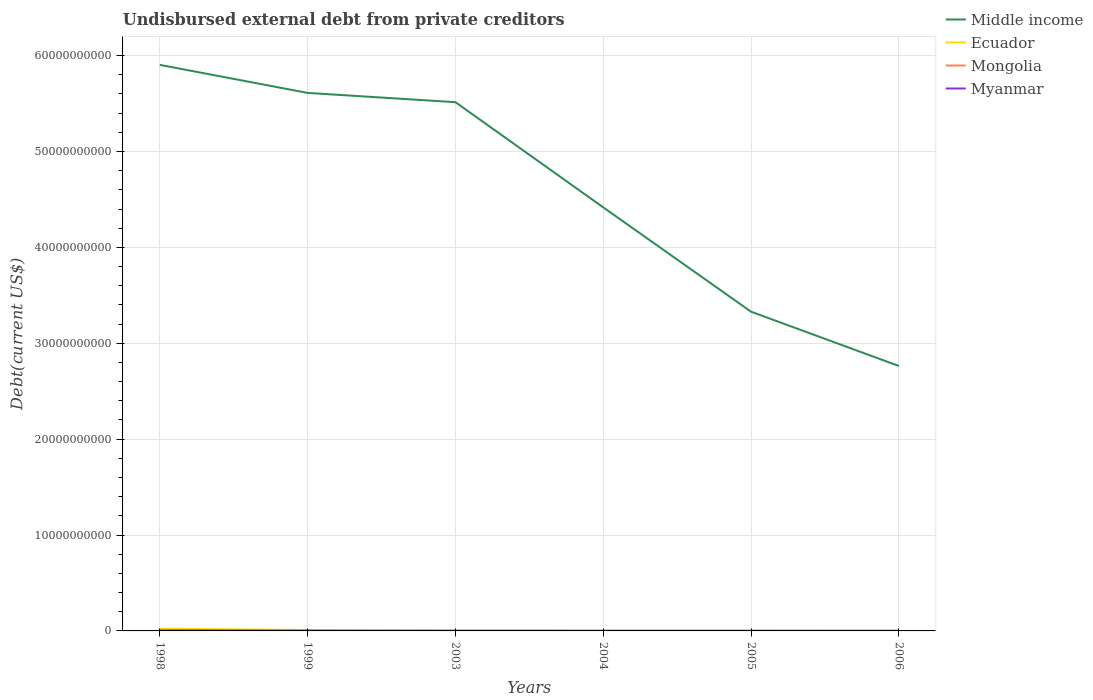How many different coloured lines are there?
Offer a terse response. 4. Is the number of lines equal to the number of legend labels?
Ensure brevity in your answer.  Yes. Across all years, what is the maximum total debt in Myanmar?
Give a very brief answer. 4.70e+04. In which year was the total debt in Myanmar maximum?
Ensure brevity in your answer.  2004. What is the total total debt in Ecuador in the graph?
Offer a terse response. 1.26e+07. What is the difference between the highest and the second highest total debt in Middle income?
Your answer should be compact. 3.14e+1. What is the difference between the highest and the lowest total debt in Middle income?
Keep it short and to the point. 3. Is the total debt in Myanmar strictly greater than the total debt in Mongolia over the years?
Provide a succinct answer. No. How many years are there in the graph?
Provide a succinct answer. 6. Are the values on the major ticks of Y-axis written in scientific E-notation?
Make the answer very short. No. Does the graph contain grids?
Your answer should be compact. Yes. How many legend labels are there?
Offer a very short reply. 4. What is the title of the graph?
Offer a very short reply. Undisbursed external debt from private creditors. What is the label or title of the Y-axis?
Your answer should be compact. Debt(current US$). What is the Debt(current US$) of Middle income in 1998?
Provide a short and direct response. 5.90e+1. What is the Debt(current US$) in Ecuador in 1998?
Offer a terse response. 2.32e+08. What is the Debt(current US$) in Mongolia in 1998?
Offer a very short reply. 8.92e+06. What is the Debt(current US$) in Myanmar in 1998?
Make the answer very short. 5.25e+07. What is the Debt(current US$) in Middle income in 1999?
Your response must be concise. 5.61e+1. What is the Debt(current US$) of Ecuador in 1999?
Provide a succinct answer. 9.39e+07. What is the Debt(current US$) in Mongolia in 1999?
Ensure brevity in your answer.  8.92e+06. What is the Debt(current US$) of Myanmar in 1999?
Your answer should be very brief. 2.32e+07. What is the Debt(current US$) in Middle income in 2003?
Your answer should be very brief. 5.51e+1. What is the Debt(current US$) of Ecuador in 2003?
Provide a short and direct response. 6.08e+07. What is the Debt(current US$) in Mongolia in 2003?
Keep it short and to the point. 2.65e+07. What is the Debt(current US$) in Myanmar in 2003?
Your answer should be compact. 1.63e+05. What is the Debt(current US$) in Middle income in 2004?
Provide a short and direct response. 4.42e+1. What is the Debt(current US$) of Ecuador in 2004?
Provide a succinct answer. 3.32e+07. What is the Debt(current US$) of Mongolia in 2004?
Your answer should be very brief. 2.65e+07. What is the Debt(current US$) of Myanmar in 2004?
Offer a terse response. 4.70e+04. What is the Debt(current US$) in Middle income in 2005?
Make the answer very short. 3.33e+1. What is the Debt(current US$) of Ecuador in 2005?
Give a very brief answer. 2.07e+07. What is the Debt(current US$) of Mongolia in 2005?
Provide a succinct answer. 2.65e+07. What is the Debt(current US$) of Myanmar in 2005?
Provide a short and direct response. 4.70e+04. What is the Debt(current US$) in Middle income in 2006?
Give a very brief answer. 2.76e+1. What is the Debt(current US$) of Ecuador in 2006?
Your answer should be compact. 4.74e+07. What is the Debt(current US$) in Mongolia in 2006?
Offer a very short reply. 8.40e+06. What is the Debt(current US$) in Myanmar in 2006?
Provide a short and direct response. 4.70e+04. Across all years, what is the maximum Debt(current US$) in Middle income?
Provide a succinct answer. 5.90e+1. Across all years, what is the maximum Debt(current US$) in Ecuador?
Make the answer very short. 2.32e+08. Across all years, what is the maximum Debt(current US$) in Mongolia?
Provide a succinct answer. 2.65e+07. Across all years, what is the maximum Debt(current US$) in Myanmar?
Your answer should be very brief. 5.25e+07. Across all years, what is the minimum Debt(current US$) in Middle income?
Your response must be concise. 2.76e+1. Across all years, what is the minimum Debt(current US$) of Ecuador?
Ensure brevity in your answer.  2.07e+07. Across all years, what is the minimum Debt(current US$) of Mongolia?
Your response must be concise. 8.40e+06. Across all years, what is the minimum Debt(current US$) of Myanmar?
Offer a terse response. 4.70e+04. What is the total Debt(current US$) of Middle income in the graph?
Ensure brevity in your answer.  2.75e+11. What is the total Debt(current US$) in Ecuador in the graph?
Make the answer very short. 4.88e+08. What is the total Debt(current US$) in Mongolia in the graph?
Offer a terse response. 1.06e+08. What is the total Debt(current US$) of Myanmar in the graph?
Your answer should be very brief. 7.60e+07. What is the difference between the Debt(current US$) of Middle income in 1998 and that in 1999?
Your answer should be very brief. 2.92e+09. What is the difference between the Debt(current US$) of Ecuador in 1998 and that in 1999?
Keep it short and to the point. 1.38e+08. What is the difference between the Debt(current US$) of Mongolia in 1998 and that in 1999?
Keep it short and to the point. 0. What is the difference between the Debt(current US$) in Myanmar in 1998 and that in 1999?
Provide a succinct answer. 2.93e+07. What is the difference between the Debt(current US$) of Middle income in 1998 and that in 2003?
Provide a short and direct response. 3.89e+09. What is the difference between the Debt(current US$) in Ecuador in 1998 and that in 2003?
Offer a very short reply. 1.71e+08. What is the difference between the Debt(current US$) of Mongolia in 1998 and that in 2003?
Make the answer very short. -1.76e+07. What is the difference between the Debt(current US$) of Myanmar in 1998 and that in 2003?
Provide a short and direct response. 5.23e+07. What is the difference between the Debt(current US$) in Middle income in 1998 and that in 2004?
Offer a very short reply. 1.49e+1. What is the difference between the Debt(current US$) in Ecuador in 1998 and that in 2004?
Your response must be concise. 1.99e+08. What is the difference between the Debt(current US$) in Mongolia in 1998 and that in 2004?
Provide a succinct answer. -1.76e+07. What is the difference between the Debt(current US$) of Myanmar in 1998 and that in 2004?
Make the answer very short. 5.24e+07. What is the difference between the Debt(current US$) in Middle income in 1998 and that in 2005?
Your answer should be compact. 2.57e+1. What is the difference between the Debt(current US$) of Ecuador in 1998 and that in 2005?
Your response must be concise. 2.12e+08. What is the difference between the Debt(current US$) in Mongolia in 1998 and that in 2005?
Offer a terse response. -1.76e+07. What is the difference between the Debt(current US$) in Myanmar in 1998 and that in 2005?
Offer a very short reply. 5.24e+07. What is the difference between the Debt(current US$) of Middle income in 1998 and that in 2006?
Provide a succinct answer. 3.14e+1. What is the difference between the Debt(current US$) in Ecuador in 1998 and that in 2006?
Your answer should be very brief. 1.85e+08. What is the difference between the Debt(current US$) of Mongolia in 1998 and that in 2006?
Make the answer very short. 5.24e+05. What is the difference between the Debt(current US$) in Myanmar in 1998 and that in 2006?
Offer a very short reply. 5.24e+07. What is the difference between the Debt(current US$) in Middle income in 1999 and that in 2003?
Give a very brief answer. 9.68e+08. What is the difference between the Debt(current US$) of Ecuador in 1999 and that in 2003?
Your answer should be very brief. 3.31e+07. What is the difference between the Debt(current US$) of Mongolia in 1999 and that in 2003?
Provide a short and direct response. -1.76e+07. What is the difference between the Debt(current US$) of Myanmar in 1999 and that in 2003?
Offer a terse response. 2.30e+07. What is the difference between the Debt(current US$) of Middle income in 1999 and that in 2004?
Your answer should be very brief. 1.19e+1. What is the difference between the Debt(current US$) of Ecuador in 1999 and that in 2004?
Keep it short and to the point. 6.07e+07. What is the difference between the Debt(current US$) of Mongolia in 1999 and that in 2004?
Give a very brief answer. -1.76e+07. What is the difference between the Debt(current US$) of Myanmar in 1999 and that in 2004?
Provide a succinct answer. 2.31e+07. What is the difference between the Debt(current US$) in Middle income in 1999 and that in 2005?
Offer a very short reply. 2.28e+1. What is the difference between the Debt(current US$) in Ecuador in 1999 and that in 2005?
Offer a terse response. 7.33e+07. What is the difference between the Debt(current US$) of Mongolia in 1999 and that in 2005?
Your answer should be very brief. -1.76e+07. What is the difference between the Debt(current US$) in Myanmar in 1999 and that in 2005?
Provide a short and direct response. 2.31e+07. What is the difference between the Debt(current US$) in Middle income in 1999 and that in 2006?
Your answer should be compact. 2.85e+1. What is the difference between the Debt(current US$) in Ecuador in 1999 and that in 2006?
Ensure brevity in your answer.  4.65e+07. What is the difference between the Debt(current US$) in Mongolia in 1999 and that in 2006?
Provide a succinct answer. 5.24e+05. What is the difference between the Debt(current US$) of Myanmar in 1999 and that in 2006?
Make the answer very short. 2.31e+07. What is the difference between the Debt(current US$) in Middle income in 2003 and that in 2004?
Offer a terse response. 1.10e+1. What is the difference between the Debt(current US$) of Ecuador in 2003 and that in 2004?
Provide a short and direct response. 2.75e+07. What is the difference between the Debt(current US$) of Mongolia in 2003 and that in 2004?
Provide a short and direct response. 0. What is the difference between the Debt(current US$) in Myanmar in 2003 and that in 2004?
Offer a terse response. 1.16e+05. What is the difference between the Debt(current US$) of Middle income in 2003 and that in 2005?
Your response must be concise. 2.18e+1. What is the difference between the Debt(current US$) of Ecuador in 2003 and that in 2005?
Give a very brief answer. 4.01e+07. What is the difference between the Debt(current US$) of Mongolia in 2003 and that in 2005?
Keep it short and to the point. 0. What is the difference between the Debt(current US$) of Myanmar in 2003 and that in 2005?
Give a very brief answer. 1.16e+05. What is the difference between the Debt(current US$) in Middle income in 2003 and that in 2006?
Ensure brevity in your answer.  2.75e+1. What is the difference between the Debt(current US$) in Ecuador in 2003 and that in 2006?
Keep it short and to the point. 1.34e+07. What is the difference between the Debt(current US$) of Mongolia in 2003 and that in 2006?
Your answer should be very brief. 1.81e+07. What is the difference between the Debt(current US$) in Myanmar in 2003 and that in 2006?
Offer a very short reply. 1.16e+05. What is the difference between the Debt(current US$) of Middle income in 2004 and that in 2005?
Provide a succinct answer. 1.09e+1. What is the difference between the Debt(current US$) in Ecuador in 2004 and that in 2005?
Provide a succinct answer. 1.26e+07. What is the difference between the Debt(current US$) of Mongolia in 2004 and that in 2005?
Make the answer very short. 0. What is the difference between the Debt(current US$) of Middle income in 2004 and that in 2006?
Your answer should be very brief. 1.65e+1. What is the difference between the Debt(current US$) of Ecuador in 2004 and that in 2006?
Your answer should be compact. -1.42e+07. What is the difference between the Debt(current US$) in Mongolia in 2004 and that in 2006?
Offer a terse response. 1.81e+07. What is the difference between the Debt(current US$) in Middle income in 2005 and that in 2006?
Give a very brief answer. 5.66e+09. What is the difference between the Debt(current US$) of Ecuador in 2005 and that in 2006?
Your answer should be compact. -2.67e+07. What is the difference between the Debt(current US$) in Mongolia in 2005 and that in 2006?
Your response must be concise. 1.81e+07. What is the difference between the Debt(current US$) in Middle income in 1998 and the Debt(current US$) in Ecuador in 1999?
Your answer should be very brief. 5.89e+1. What is the difference between the Debt(current US$) of Middle income in 1998 and the Debt(current US$) of Mongolia in 1999?
Offer a terse response. 5.90e+1. What is the difference between the Debt(current US$) of Middle income in 1998 and the Debt(current US$) of Myanmar in 1999?
Ensure brevity in your answer.  5.90e+1. What is the difference between the Debt(current US$) in Ecuador in 1998 and the Debt(current US$) in Mongolia in 1999?
Offer a very short reply. 2.23e+08. What is the difference between the Debt(current US$) of Ecuador in 1998 and the Debt(current US$) of Myanmar in 1999?
Your answer should be very brief. 2.09e+08. What is the difference between the Debt(current US$) of Mongolia in 1998 and the Debt(current US$) of Myanmar in 1999?
Give a very brief answer. -1.42e+07. What is the difference between the Debt(current US$) in Middle income in 1998 and the Debt(current US$) in Ecuador in 2003?
Provide a short and direct response. 5.90e+1. What is the difference between the Debt(current US$) in Middle income in 1998 and the Debt(current US$) in Mongolia in 2003?
Ensure brevity in your answer.  5.90e+1. What is the difference between the Debt(current US$) of Middle income in 1998 and the Debt(current US$) of Myanmar in 2003?
Offer a terse response. 5.90e+1. What is the difference between the Debt(current US$) in Ecuador in 1998 and the Debt(current US$) in Mongolia in 2003?
Keep it short and to the point. 2.06e+08. What is the difference between the Debt(current US$) of Ecuador in 1998 and the Debt(current US$) of Myanmar in 2003?
Provide a succinct answer. 2.32e+08. What is the difference between the Debt(current US$) in Mongolia in 1998 and the Debt(current US$) in Myanmar in 2003?
Your response must be concise. 8.76e+06. What is the difference between the Debt(current US$) of Middle income in 1998 and the Debt(current US$) of Ecuador in 2004?
Give a very brief answer. 5.90e+1. What is the difference between the Debt(current US$) in Middle income in 1998 and the Debt(current US$) in Mongolia in 2004?
Offer a very short reply. 5.90e+1. What is the difference between the Debt(current US$) in Middle income in 1998 and the Debt(current US$) in Myanmar in 2004?
Give a very brief answer. 5.90e+1. What is the difference between the Debt(current US$) of Ecuador in 1998 and the Debt(current US$) of Mongolia in 2004?
Offer a very short reply. 2.06e+08. What is the difference between the Debt(current US$) in Ecuador in 1998 and the Debt(current US$) in Myanmar in 2004?
Provide a succinct answer. 2.32e+08. What is the difference between the Debt(current US$) of Mongolia in 1998 and the Debt(current US$) of Myanmar in 2004?
Provide a succinct answer. 8.88e+06. What is the difference between the Debt(current US$) in Middle income in 1998 and the Debt(current US$) in Ecuador in 2005?
Offer a terse response. 5.90e+1. What is the difference between the Debt(current US$) in Middle income in 1998 and the Debt(current US$) in Mongolia in 2005?
Your answer should be very brief. 5.90e+1. What is the difference between the Debt(current US$) in Middle income in 1998 and the Debt(current US$) in Myanmar in 2005?
Your response must be concise. 5.90e+1. What is the difference between the Debt(current US$) of Ecuador in 1998 and the Debt(current US$) of Mongolia in 2005?
Keep it short and to the point. 2.06e+08. What is the difference between the Debt(current US$) of Ecuador in 1998 and the Debt(current US$) of Myanmar in 2005?
Offer a very short reply. 2.32e+08. What is the difference between the Debt(current US$) of Mongolia in 1998 and the Debt(current US$) of Myanmar in 2005?
Your answer should be very brief. 8.88e+06. What is the difference between the Debt(current US$) in Middle income in 1998 and the Debt(current US$) in Ecuador in 2006?
Offer a very short reply. 5.90e+1. What is the difference between the Debt(current US$) of Middle income in 1998 and the Debt(current US$) of Mongolia in 2006?
Your response must be concise. 5.90e+1. What is the difference between the Debt(current US$) of Middle income in 1998 and the Debt(current US$) of Myanmar in 2006?
Your answer should be very brief. 5.90e+1. What is the difference between the Debt(current US$) in Ecuador in 1998 and the Debt(current US$) in Mongolia in 2006?
Ensure brevity in your answer.  2.24e+08. What is the difference between the Debt(current US$) in Ecuador in 1998 and the Debt(current US$) in Myanmar in 2006?
Your answer should be very brief. 2.32e+08. What is the difference between the Debt(current US$) in Mongolia in 1998 and the Debt(current US$) in Myanmar in 2006?
Your response must be concise. 8.88e+06. What is the difference between the Debt(current US$) in Middle income in 1999 and the Debt(current US$) in Ecuador in 2003?
Give a very brief answer. 5.60e+1. What is the difference between the Debt(current US$) in Middle income in 1999 and the Debt(current US$) in Mongolia in 2003?
Keep it short and to the point. 5.61e+1. What is the difference between the Debt(current US$) in Middle income in 1999 and the Debt(current US$) in Myanmar in 2003?
Offer a terse response. 5.61e+1. What is the difference between the Debt(current US$) in Ecuador in 1999 and the Debt(current US$) in Mongolia in 2003?
Give a very brief answer. 6.74e+07. What is the difference between the Debt(current US$) of Ecuador in 1999 and the Debt(current US$) of Myanmar in 2003?
Keep it short and to the point. 9.38e+07. What is the difference between the Debt(current US$) in Mongolia in 1999 and the Debt(current US$) in Myanmar in 2003?
Ensure brevity in your answer.  8.76e+06. What is the difference between the Debt(current US$) of Middle income in 1999 and the Debt(current US$) of Ecuador in 2004?
Provide a short and direct response. 5.61e+1. What is the difference between the Debt(current US$) of Middle income in 1999 and the Debt(current US$) of Mongolia in 2004?
Your answer should be very brief. 5.61e+1. What is the difference between the Debt(current US$) of Middle income in 1999 and the Debt(current US$) of Myanmar in 2004?
Offer a terse response. 5.61e+1. What is the difference between the Debt(current US$) of Ecuador in 1999 and the Debt(current US$) of Mongolia in 2004?
Give a very brief answer. 6.74e+07. What is the difference between the Debt(current US$) of Ecuador in 1999 and the Debt(current US$) of Myanmar in 2004?
Your answer should be very brief. 9.39e+07. What is the difference between the Debt(current US$) in Mongolia in 1999 and the Debt(current US$) in Myanmar in 2004?
Offer a terse response. 8.88e+06. What is the difference between the Debt(current US$) of Middle income in 1999 and the Debt(current US$) of Ecuador in 2005?
Make the answer very short. 5.61e+1. What is the difference between the Debt(current US$) of Middle income in 1999 and the Debt(current US$) of Mongolia in 2005?
Offer a terse response. 5.61e+1. What is the difference between the Debt(current US$) of Middle income in 1999 and the Debt(current US$) of Myanmar in 2005?
Your response must be concise. 5.61e+1. What is the difference between the Debt(current US$) of Ecuador in 1999 and the Debt(current US$) of Mongolia in 2005?
Give a very brief answer. 6.74e+07. What is the difference between the Debt(current US$) in Ecuador in 1999 and the Debt(current US$) in Myanmar in 2005?
Your response must be concise. 9.39e+07. What is the difference between the Debt(current US$) of Mongolia in 1999 and the Debt(current US$) of Myanmar in 2005?
Give a very brief answer. 8.88e+06. What is the difference between the Debt(current US$) in Middle income in 1999 and the Debt(current US$) in Ecuador in 2006?
Your answer should be compact. 5.61e+1. What is the difference between the Debt(current US$) of Middle income in 1999 and the Debt(current US$) of Mongolia in 2006?
Make the answer very short. 5.61e+1. What is the difference between the Debt(current US$) of Middle income in 1999 and the Debt(current US$) of Myanmar in 2006?
Keep it short and to the point. 5.61e+1. What is the difference between the Debt(current US$) in Ecuador in 1999 and the Debt(current US$) in Mongolia in 2006?
Your answer should be compact. 8.55e+07. What is the difference between the Debt(current US$) in Ecuador in 1999 and the Debt(current US$) in Myanmar in 2006?
Your response must be concise. 9.39e+07. What is the difference between the Debt(current US$) of Mongolia in 1999 and the Debt(current US$) of Myanmar in 2006?
Ensure brevity in your answer.  8.88e+06. What is the difference between the Debt(current US$) in Middle income in 2003 and the Debt(current US$) in Ecuador in 2004?
Your response must be concise. 5.51e+1. What is the difference between the Debt(current US$) in Middle income in 2003 and the Debt(current US$) in Mongolia in 2004?
Your response must be concise. 5.51e+1. What is the difference between the Debt(current US$) in Middle income in 2003 and the Debt(current US$) in Myanmar in 2004?
Offer a terse response. 5.51e+1. What is the difference between the Debt(current US$) of Ecuador in 2003 and the Debt(current US$) of Mongolia in 2004?
Your answer should be very brief. 3.43e+07. What is the difference between the Debt(current US$) of Ecuador in 2003 and the Debt(current US$) of Myanmar in 2004?
Offer a very short reply. 6.07e+07. What is the difference between the Debt(current US$) of Mongolia in 2003 and the Debt(current US$) of Myanmar in 2004?
Your answer should be compact. 2.65e+07. What is the difference between the Debt(current US$) in Middle income in 2003 and the Debt(current US$) in Ecuador in 2005?
Your answer should be very brief. 5.51e+1. What is the difference between the Debt(current US$) of Middle income in 2003 and the Debt(current US$) of Mongolia in 2005?
Ensure brevity in your answer.  5.51e+1. What is the difference between the Debt(current US$) of Middle income in 2003 and the Debt(current US$) of Myanmar in 2005?
Offer a terse response. 5.51e+1. What is the difference between the Debt(current US$) of Ecuador in 2003 and the Debt(current US$) of Mongolia in 2005?
Your answer should be very brief. 3.43e+07. What is the difference between the Debt(current US$) in Ecuador in 2003 and the Debt(current US$) in Myanmar in 2005?
Provide a succinct answer. 6.07e+07. What is the difference between the Debt(current US$) in Mongolia in 2003 and the Debt(current US$) in Myanmar in 2005?
Your answer should be very brief. 2.65e+07. What is the difference between the Debt(current US$) of Middle income in 2003 and the Debt(current US$) of Ecuador in 2006?
Provide a succinct answer. 5.51e+1. What is the difference between the Debt(current US$) of Middle income in 2003 and the Debt(current US$) of Mongolia in 2006?
Ensure brevity in your answer.  5.51e+1. What is the difference between the Debt(current US$) of Middle income in 2003 and the Debt(current US$) of Myanmar in 2006?
Keep it short and to the point. 5.51e+1. What is the difference between the Debt(current US$) in Ecuador in 2003 and the Debt(current US$) in Mongolia in 2006?
Provide a succinct answer. 5.24e+07. What is the difference between the Debt(current US$) of Ecuador in 2003 and the Debt(current US$) of Myanmar in 2006?
Keep it short and to the point. 6.07e+07. What is the difference between the Debt(current US$) of Mongolia in 2003 and the Debt(current US$) of Myanmar in 2006?
Offer a very short reply. 2.65e+07. What is the difference between the Debt(current US$) of Middle income in 2004 and the Debt(current US$) of Ecuador in 2005?
Ensure brevity in your answer.  4.42e+1. What is the difference between the Debt(current US$) of Middle income in 2004 and the Debt(current US$) of Mongolia in 2005?
Ensure brevity in your answer.  4.41e+1. What is the difference between the Debt(current US$) of Middle income in 2004 and the Debt(current US$) of Myanmar in 2005?
Keep it short and to the point. 4.42e+1. What is the difference between the Debt(current US$) in Ecuador in 2004 and the Debt(current US$) in Mongolia in 2005?
Make the answer very short. 6.74e+06. What is the difference between the Debt(current US$) in Ecuador in 2004 and the Debt(current US$) in Myanmar in 2005?
Ensure brevity in your answer.  3.32e+07. What is the difference between the Debt(current US$) in Mongolia in 2004 and the Debt(current US$) in Myanmar in 2005?
Your answer should be very brief. 2.65e+07. What is the difference between the Debt(current US$) of Middle income in 2004 and the Debt(current US$) of Ecuador in 2006?
Your response must be concise. 4.41e+1. What is the difference between the Debt(current US$) of Middle income in 2004 and the Debt(current US$) of Mongolia in 2006?
Offer a very short reply. 4.42e+1. What is the difference between the Debt(current US$) in Middle income in 2004 and the Debt(current US$) in Myanmar in 2006?
Ensure brevity in your answer.  4.42e+1. What is the difference between the Debt(current US$) of Ecuador in 2004 and the Debt(current US$) of Mongolia in 2006?
Your response must be concise. 2.48e+07. What is the difference between the Debt(current US$) of Ecuador in 2004 and the Debt(current US$) of Myanmar in 2006?
Provide a succinct answer. 3.32e+07. What is the difference between the Debt(current US$) of Mongolia in 2004 and the Debt(current US$) of Myanmar in 2006?
Keep it short and to the point. 2.65e+07. What is the difference between the Debt(current US$) in Middle income in 2005 and the Debt(current US$) in Ecuador in 2006?
Provide a short and direct response. 3.32e+1. What is the difference between the Debt(current US$) of Middle income in 2005 and the Debt(current US$) of Mongolia in 2006?
Ensure brevity in your answer.  3.33e+1. What is the difference between the Debt(current US$) in Middle income in 2005 and the Debt(current US$) in Myanmar in 2006?
Your response must be concise. 3.33e+1. What is the difference between the Debt(current US$) in Ecuador in 2005 and the Debt(current US$) in Mongolia in 2006?
Offer a terse response. 1.23e+07. What is the difference between the Debt(current US$) in Ecuador in 2005 and the Debt(current US$) in Myanmar in 2006?
Provide a succinct answer. 2.06e+07. What is the difference between the Debt(current US$) in Mongolia in 2005 and the Debt(current US$) in Myanmar in 2006?
Offer a terse response. 2.65e+07. What is the average Debt(current US$) in Middle income per year?
Your answer should be compact. 4.59e+1. What is the average Debt(current US$) of Ecuador per year?
Offer a terse response. 8.14e+07. What is the average Debt(current US$) of Mongolia per year?
Your response must be concise. 1.76e+07. What is the average Debt(current US$) in Myanmar per year?
Provide a short and direct response. 1.27e+07. In the year 1998, what is the difference between the Debt(current US$) of Middle income and Debt(current US$) of Ecuador?
Your answer should be very brief. 5.88e+1. In the year 1998, what is the difference between the Debt(current US$) of Middle income and Debt(current US$) of Mongolia?
Your answer should be very brief. 5.90e+1. In the year 1998, what is the difference between the Debt(current US$) of Middle income and Debt(current US$) of Myanmar?
Your answer should be very brief. 5.90e+1. In the year 1998, what is the difference between the Debt(current US$) in Ecuador and Debt(current US$) in Mongolia?
Your response must be concise. 2.23e+08. In the year 1998, what is the difference between the Debt(current US$) of Ecuador and Debt(current US$) of Myanmar?
Make the answer very short. 1.80e+08. In the year 1998, what is the difference between the Debt(current US$) in Mongolia and Debt(current US$) in Myanmar?
Your response must be concise. -4.36e+07. In the year 1999, what is the difference between the Debt(current US$) in Middle income and Debt(current US$) in Ecuador?
Provide a short and direct response. 5.60e+1. In the year 1999, what is the difference between the Debt(current US$) of Middle income and Debt(current US$) of Mongolia?
Give a very brief answer. 5.61e+1. In the year 1999, what is the difference between the Debt(current US$) of Middle income and Debt(current US$) of Myanmar?
Your answer should be very brief. 5.61e+1. In the year 1999, what is the difference between the Debt(current US$) in Ecuador and Debt(current US$) in Mongolia?
Offer a terse response. 8.50e+07. In the year 1999, what is the difference between the Debt(current US$) in Ecuador and Debt(current US$) in Myanmar?
Provide a succinct answer. 7.08e+07. In the year 1999, what is the difference between the Debt(current US$) in Mongolia and Debt(current US$) in Myanmar?
Offer a very short reply. -1.42e+07. In the year 2003, what is the difference between the Debt(current US$) of Middle income and Debt(current US$) of Ecuador?
Offer a terse response. 5.51e+1. In the year 2003, what is the difference between the Debt(current US$) in Middle income and Debt(current US$) in Mongolia?
Offer a very short reply. 5.51e+1. In the year 2003, what is the difference between the Debt(current US$) in Middle income and Debt(current US$) in Myanmar?
Keep it short and to the point. 5.51e+1. In the year 2003, what is the difference between the Debt(current US$) in Ecuador and Debt(current US$) in Mongolia?
Offer a terse response. 3.43e+07. In the year 2003, what is the difference between the Debt(current US$) of Ecuador and Debt(current US$) of Myanmar?
Keep it short and to the point. 6.06e+07. In the year 2003, what is the difference between the Debt(current US$) of Mongolia and Debt(current US$) of Myanmar?
Offer a very short reply. 2.63e+07. In the year 2004, what is the difference between the Debt(current US$) in Middle income and Debt(current US$) in Ecuador?
Your answer should be very brief. 4.41e+1. In the year 2004, what is the difference between the Debt(current US$) of Middle income and Debt(current US$) of Mongolia?
Ensure brevity in your answer.  4.41e+1. In the year 2004, what is the difference between the Debt(current US$) in Middle income and Debt(current US$) in Myanmar?
Offer a very short reply. 4.42e+1. In the year 2004, what is the difference between the Debt(current US$) in Ecuador and Debt(current US$) in Mongolia?
Give a very brief answer. 6.74e+06. In the year 2004, what is the difference between the Debt(current US$) of Ecuador and Debt(current US$) of Myanmar?
Give a very brief answer. 3.32e+07. In the year 2004, what is the difference between the Debt(current US$) of Mongolia and Debt(current US$) of Myanmar?
Provide a short and direct response. 2.65e+07. In the year 2005, what is the difference between the Debt(current US$) of Middle income and Debt(current US$) of Ecuador?
Give a very brief answer. 3.33e+1. In the year 2005, what is the difference between the Debt(current US$) in Middle income and Debt(current US$) in Mongolia?
Your response must be concise. 3.33e+1. In the year 2005, what is the difference between the Debt(current US$) in Middle income and Debt(current US$) in Myanmar?
Provide a short and direct response. 3.33e+1. In the year 2005, what is the difference between the Debt(current US$) of Ecuador and Debt(current US$) of Mongolia?
Give a very brief answer. -5.84e+06. In the year 2005, what is the difference between the Debt(current US$) of Ecuador and Debt(current US$) of Myanmar?
Keep it short and to the point. 2.06e+07. In the year 2005, what is the difference between the Debt(current US$) of Mongolia and Debt(current US$) of Myanmar?
Give a very brief answer. 2.65e+07. In the year 2006, what is the difference between the Debt(current US$) of Middle income and Debt(current US$) of Ecuador?
Provide a short and direct response. 2.76e+1. In the year 2006, what is the difference between the Debt(current US$) of Middle income and Debt(current US$) of Mongolia?
Keep it short and to the point. 2.76e+1. In the year 2006, what is the difference between the Debt(current US$) of Middle income and Debt(current US$) of Myanmar?
Offer a terse response. 2.76e+1. In the year 2006, what is the difference between the Debt(current US$) of Ecuador and Debt(current US$) of Mongolia?
Provide a succinct answer. 3.90e+07. In the year 2006, what is the difference between the Debt(current US$) in Ecuador and Debt(current US$) in Myanmar?
Provide a succinct answer. 4.73e+07. In the year 2006, what is the difference between the Debt(current US$) in Mongolia and Debt(current US$) in Myanmar?
Ensure brevity in your answer.  8.35e+06. What is the ratio of the Debt(current US$) of Middle income in 1998 to that in 1999?
Provide a short and direct response. 1.05. What is the ratio of the Debt(current US$) of Ecuador in 1998 to that in 1999?
Your response must be concise. 2.47. What is the ratio of the Debt(current US$) of Mongolia in 1998 to that in 1999?
Provide a short and direct response. 1. What is the ratio of the Debt(current US$) of Myanmar in 1998 to that in 1999?
Keep it short and to the point. 2.27. What is the ratio of the Debt(current US$) in Middle income in 1998 to that in 2003?
Your answer should be compact. 1.07. What is the ratio of the Debt(current US$) of Ecuador in 1998 to that in 2003?
Keep it short and to the point. 3.82. What is the ratio of the Debt(current US$) of Mongolia in 1998 to that in 2003?
Provide a short and direct response. 0.34. What is the ratio of the Debt(current US$) in Myanmar in 1998 to that in 2003?
Offer a very short reply. 322.03. What is the ratio of the Debt(current US$) of Middle income in 1998 to that in 2004?
Make the answer very short. 1.34. What is the ratio of the Debt(current US$) in Ecuador in 1998 to that in 2004?
Offer a very short reply. 6.99. What is the ratio of the Debt(current US$) in Mongolia in 1998 to that in 2004?
Keep it short and to the point. 0.34. What is the ratio of the Debt(current US$) in Myanmar in 1998 to that in 2004?
Give a very brief answer. 1116.83. What is the ratio of the Debt(current US$) in Middle income in 1998 to that in 2005?
Your response must be concise. 1.77. What is the ratio of the Debt(current US$) of Ecuador in 1998 to that in 2005?
Your answer should be compact. 11.24. What is the ratio of the Debt(current US$) of Mongolia in 1998 to that in 2005?
Keep it short and to the point. 0.34. What is the ratio of the Debt(current US$) of Myanmar in 1998 to that in 2005?
Provide a succinct answer. 1116.83. What is the ratio of the Debt(current US$) in Middle income in 1998 to that in 2006?
Offer a very short reply. 2.14. What is the ratio of the Debt(current US$) of Ecuador in 1998 to that in 2006?
Your answer should be very brief. 4.9. What is the ratio of the Debt(current US$) of Mongolia in 1998 to that in 2006?
Offer a terse response. 1.06. What is the ratio of the Debt(current US$) in Myanmar in 1998 to that in 2006?
Your answer should be compact. 1116.83. What is the ratio of the Debt(current US$) in Middle income in 1999 to that in 2003?
Your response must be concise. 1.02. What is the ratio of the Debt(current US$) in Ecuador in 1999 to that in 2003?
Keep it short and to the point. 1.55. What is the ratio of the Debt(current US$) in Mongolia in 1999 to that in 2003?
Keep it short and to the point. 0.34. What is the ratio of the Debt(current US$) in Myanmar in 1999 to that in 2003?
Give a very brief answer. 142.1. What is the ratio of the Debt(current US$) in Middle income in 1999 to that in 2004?
Offer a terse response. 1.27. What is the ratio of the Debt(current US$) of Ecuador in 1999 to that in 2004?
Provide a short and direct response. 2.83. What is the ratio of the Debt(current US$) of Mongolia in 1999 to that in 2004?
Your answer should be compact. 0.34. What is the ratio of the Debt(current US$) in Myanmar in 1999 to that in 2004?
Offer a very short reply. 492.83. What is the ratio of the Debt(current US$) in Middle income in 1999 to that in 2005?
Provide a short and direct response. 1.69. What is the ratio of the Debt(current US$) in Ecuador in 1999 to that in 2005?
Provide a short and direct response. 4.55. What is the ratio of the Debt(current US$) in Mongolia in 1999 to that in 2005?
Ensure brevity in your answer.  0.34. What is the ratio of the Debt(current US$) of Myanmar in 1999 to that in 2005?
Offer a very short reply. 492.83. What is the ratio of the Debt(current US$) of Middle income in 1999 to that in 2006?
Your response must be concise. 2.03. What is the ratio of the Debt(current US$) of Ecuador in 1999 to that in 2006?
Provide a short and direct response. 1.98. What is the ratio of the Debt(current US$) of Mongolia in 1999 to that in 2006?
Your response must be concise. 1.06. What is the ratio of the Debt(current US$) in Myanmar in 1999 to that in 2006?
Make the answer very short. 492.83. What is the ratio of the Debt(current US$) in Middle income in 2003 to that in 2004?
Ensure brevity in your answer.  1.25. What is the ratio of the Debt(current US$) in Ecuador in 2003 to that in 2004?
Provide a succinct answer. 1.83. What is the ratio of the Debt(current US$) of Mongolia in 2003 to that in 2004?
Provide a succinct answer. 1. What is the ratio of the Debt(current US$) in Myanmar in 2003 to that in 2004?
Your response must be concise. 3.47. What is the ratio of the Debt(current US$) of Middle income in 2003 to that in 2005?
Ensure brevity in your answer.  1.66. What is the ratio of the Debt(current US$) of Ecuador in 2003 to that in 2005?
Ensure brevity in your answer.  2.94. What is the ratio of the Debt(current US$) of Mongolia in 2003 to that in 2005?
Your answer should be compact. 1. What is the ratio of the Debt(current US$) of Myanmar in 2003 to that in 2005?
Provide a succinct answer. 3.47. What is the ratio of the Debt(current US$) in Middle income in 2003 to that in 2006?
Make the answer very short. 2. What is the ratio of the Debt(current US$) in Ecuador in 2003 to that in 2006?
Provide a short and direct response. 1.28. What is the ratio of the Debt(current US$) of Mongolia in 2003 to that in 2006?
Provide a succinct answer. 3.15. What is the ratio of the Debt(current US$) in Myanmar in 2003 to that in 2006?
Make the answer very short. 3.47. What is the ratio of the Debt(current US$) in Middle income in 2004 to that in 2005?
Make the answer very short. 1.33. What is the ratio of the Debt(current US$) of Ecuador in 2004 to that in 2005?
Your response must be concise. 1.61. What is the ratio of the Debt(current US$) in Myanmar in 2004 to that in 2005?
Your answer should be very brief. 1. What is the ratio of the Debt(current US$) of Middle income in 2004 to that in 2006?
Provide a short and direct response. 1.6. What is the ratio of the Debt(current US$) of Ecuador in 2004 to that in 2006?
Your response must be concise. 0.7. What is the ratio of the Debt(current US$) of Mongolia in 2004 to that in 2006?
Ensure brevity in your answer.  3.15. What is the ratio of the Debt(current US$) of Middle income in 2005 to that in 2006?
Your answer should be very brief. 1.2. What is the ratio of the Debt(current US$) of Ecuador in 2005 to that in 2006?
Ensure brevity in your answer.  0.44. What is the ratio of the Debt(current US$) of Mongolia in 2005 to that in 2006?
Ensure brevity in your answer.  3.15. What is the difference between the highest and the second highest Debt(current US$) in Middle income?
Provide a short and direct response. 2.92e+09. What is the difference between the highest and the second highest Debt(current US$) of Ecuador?
Offer a very short reply. 1.38e+08. What is the difference between the highest and the second highest Debt(current US$) of Mongolia?
Give a very brief answer. 0. What is the difference between the highest and the second highest Debt(current US$) of Myanmar?
Offer a very short reply. 2.93e+07. What is the difference between the highest and the lowest Debt(current US$) in Middle income?
Provide a succinct answer. 3.14e+1. What is the difference between the highest and the lowest Debt(current US$) in Ecuador?
Keep it short and to the point. 2.12e+08. What is the difference between the highest and the lowest Debt(current US$) in Mongolia?
Give a very brief answer. 1.81e+07. What is the difference between the highest and the lowest Debt(current US$) in Myanmar?
Offer a very short reply. 5.24e+07. 